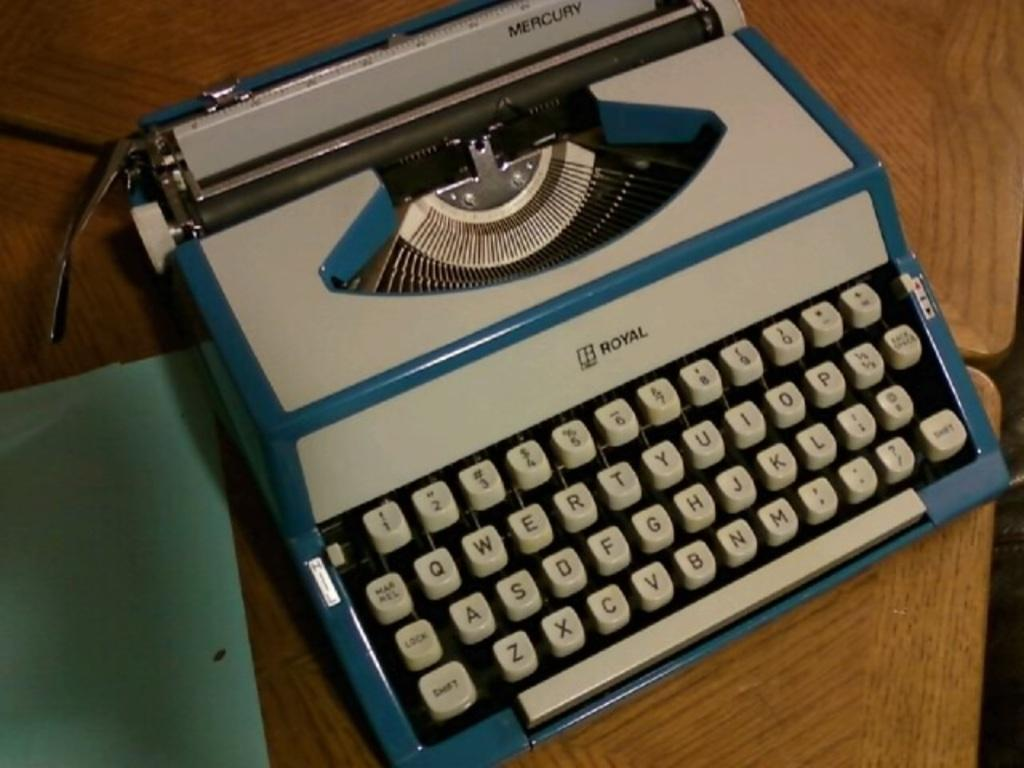<image>
Describe the image concisely. A Royal typewriter rests on top of wooden desk. 